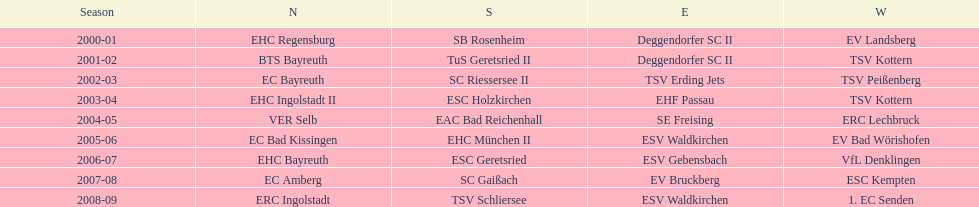Who won the south after esc geretsried did during the 2006-07 season? SC Gaißach. 